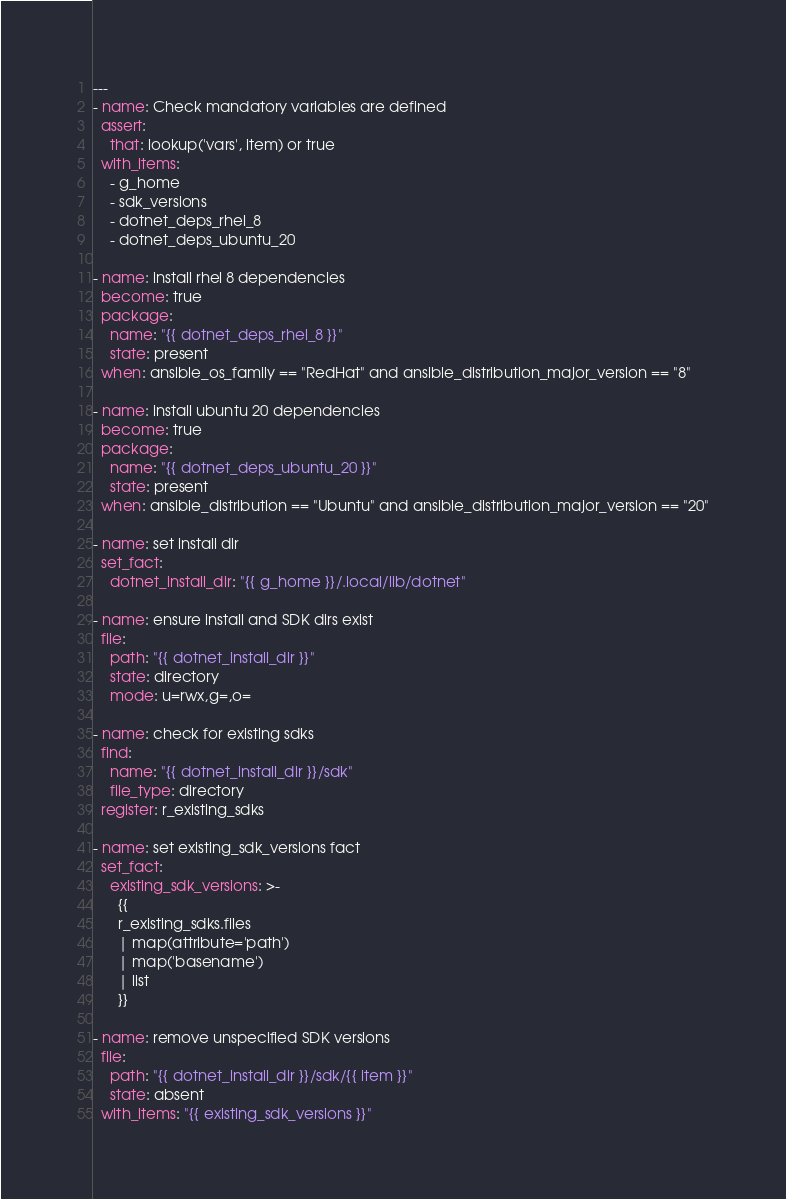<code> <loc_0><loc_0><loc_500><loc_500><_YAML_>---
- name: Check mandatory variables are defined
  assert:
    that: lookup('vars', item) or true
  with_items:
    - g_home
    - sdk_versions
    - dotnet_deps_rhel_8
    - dotnet_deps_ubuntu_20

- name: install rhel 8 dependencies
  become: true
  package:
    name: "{{ dotnet_deps_rhel_8 }}"
    state: present
  when: ansible_os_family == "RedHat" and ansible_distribution_major_version == "8"

- name: install ubuntu 20 dependencies
  become: true
  package:
    name: "{{ dotnet_deps_ubuntu_20 }}"
    state: present
  when: ansible_distribution == "Ubuntu" and ansible_distribution_major_version == "20"

- name: set install dir
  set_fact:
    dotnet_install_dir: "{{ g_home }}/.local/lib/dotnet"

- name: ensure install and SDK dirs exist
  file:
    path: "{{ dotnet_install_dir }}"
    state: directory
    mode: u=rwx,g=,o=

- name: check for existing sdks
  find:
    name: "{{ dotnet_install_dir }}/sdk"
    file_type: directory
  register: r_existing_sdks

- name: set existing_sdk_versions fact
  set_fact:
    existing_sdk_versions: >-
      {{
      r_existing_sdks.files
      | map(attribute='path')
      | map('basename')
      | list
      }}

- name: remove unspecified SDK versions
  file:
    path: "{{ dotnet_install_dir }}/sdk/{{ item }}"
    state: absent
  with_items: "{{ existing_sdk_versions }}"</code> 